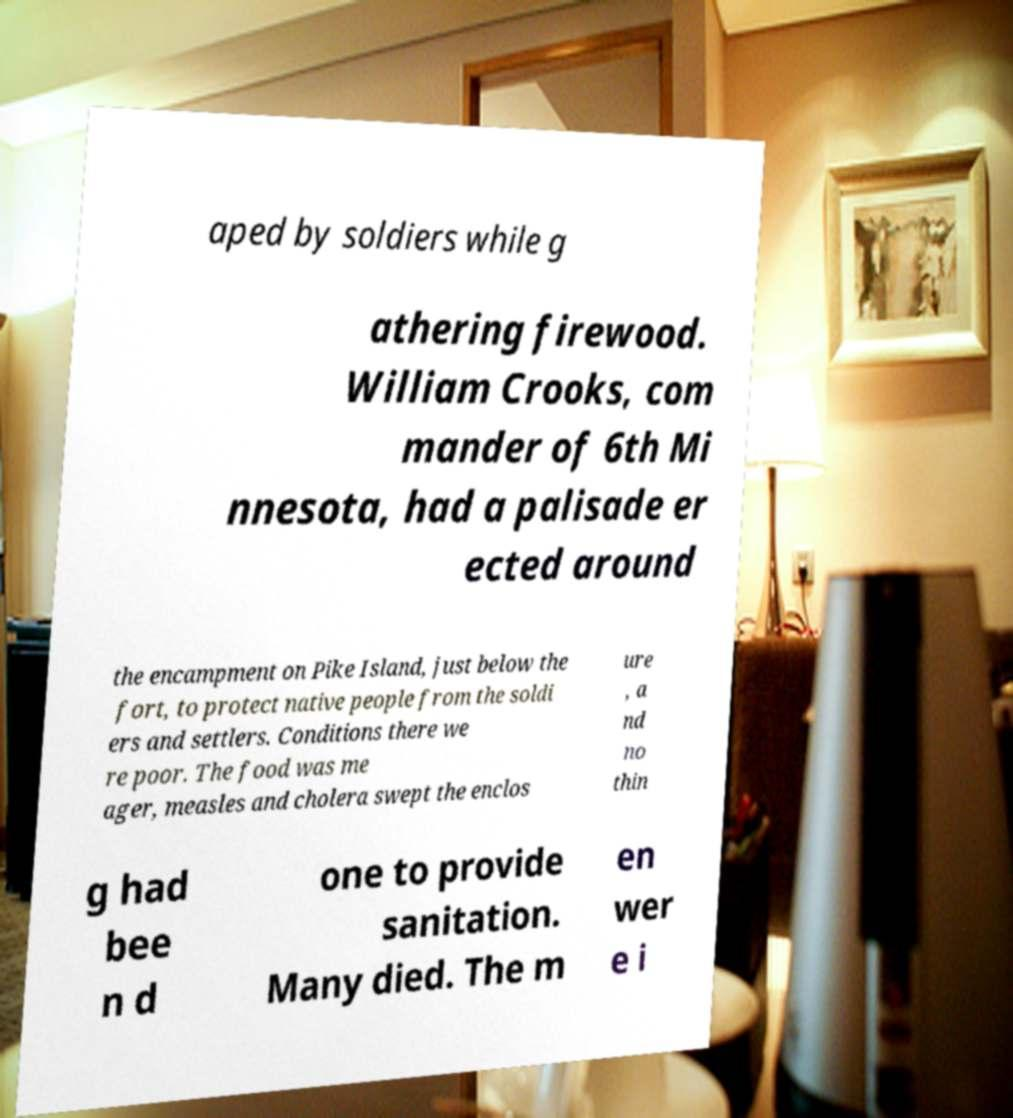There's text embedded in this image that I need extracted. Can you transcribe it verbatim? aped by soldiers while g athering firewood. William Crooks, com mander of 6th Mi nnesota, had a palisade er ected around the encampment on Pike Island, just below the fort, to protect native people from the soldi ers and settlers. Conditions there we re poor. The food was me ager, measles and cholera swept the enclos ure , a nd no thin g had bee n d one to provide sanitation. Many died. The m en wer e i 